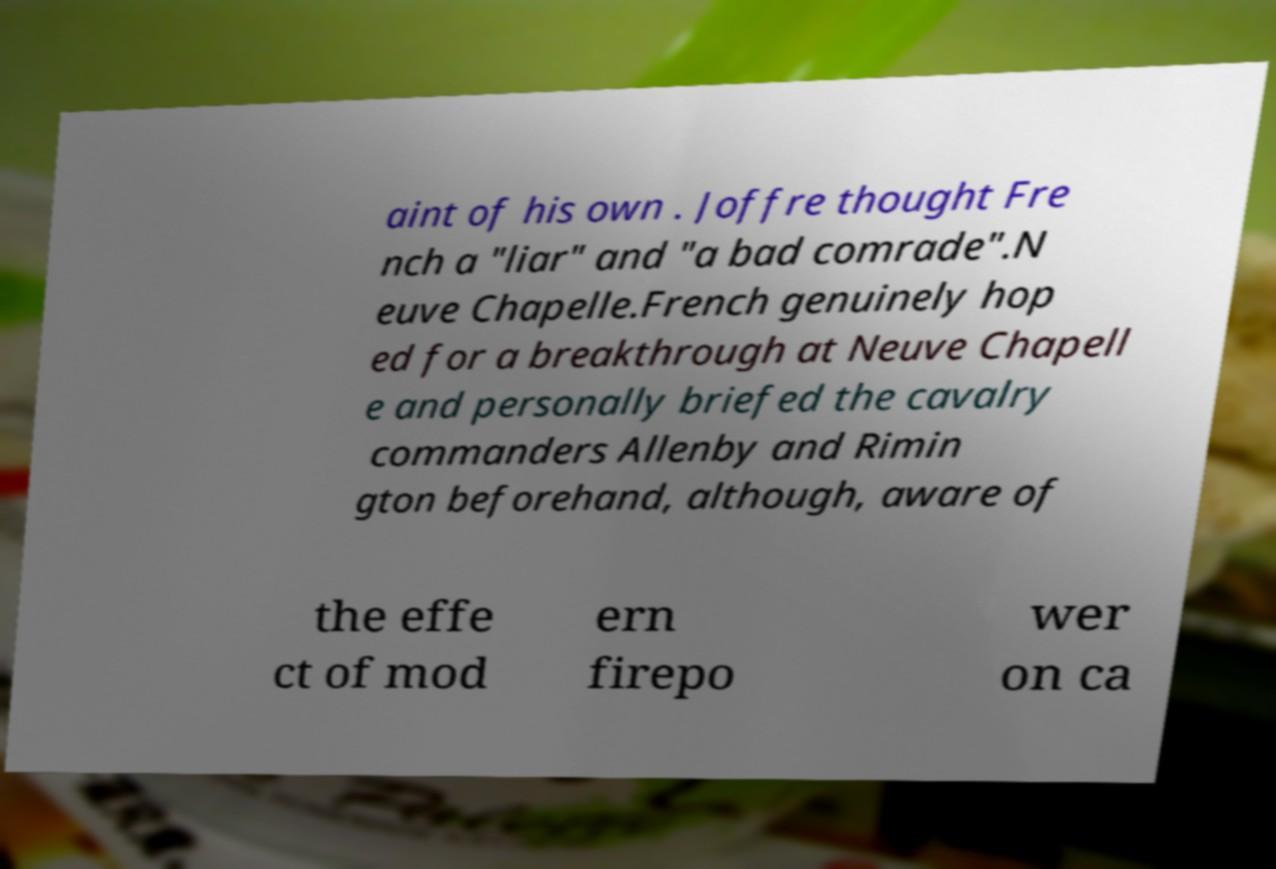Could you extract and type out the text from this image? aint of his own . Joffre thought Fre nch a "liar" and "a bad comrade".N euve Chapelle.French genuinely hop ed for a breakthrough at Neuve Chapell e and personally briefed the cavalry commanders Allenby and Rimin gton beforehand, although, aware of the effe ct of mod ern firepo wer on ca 